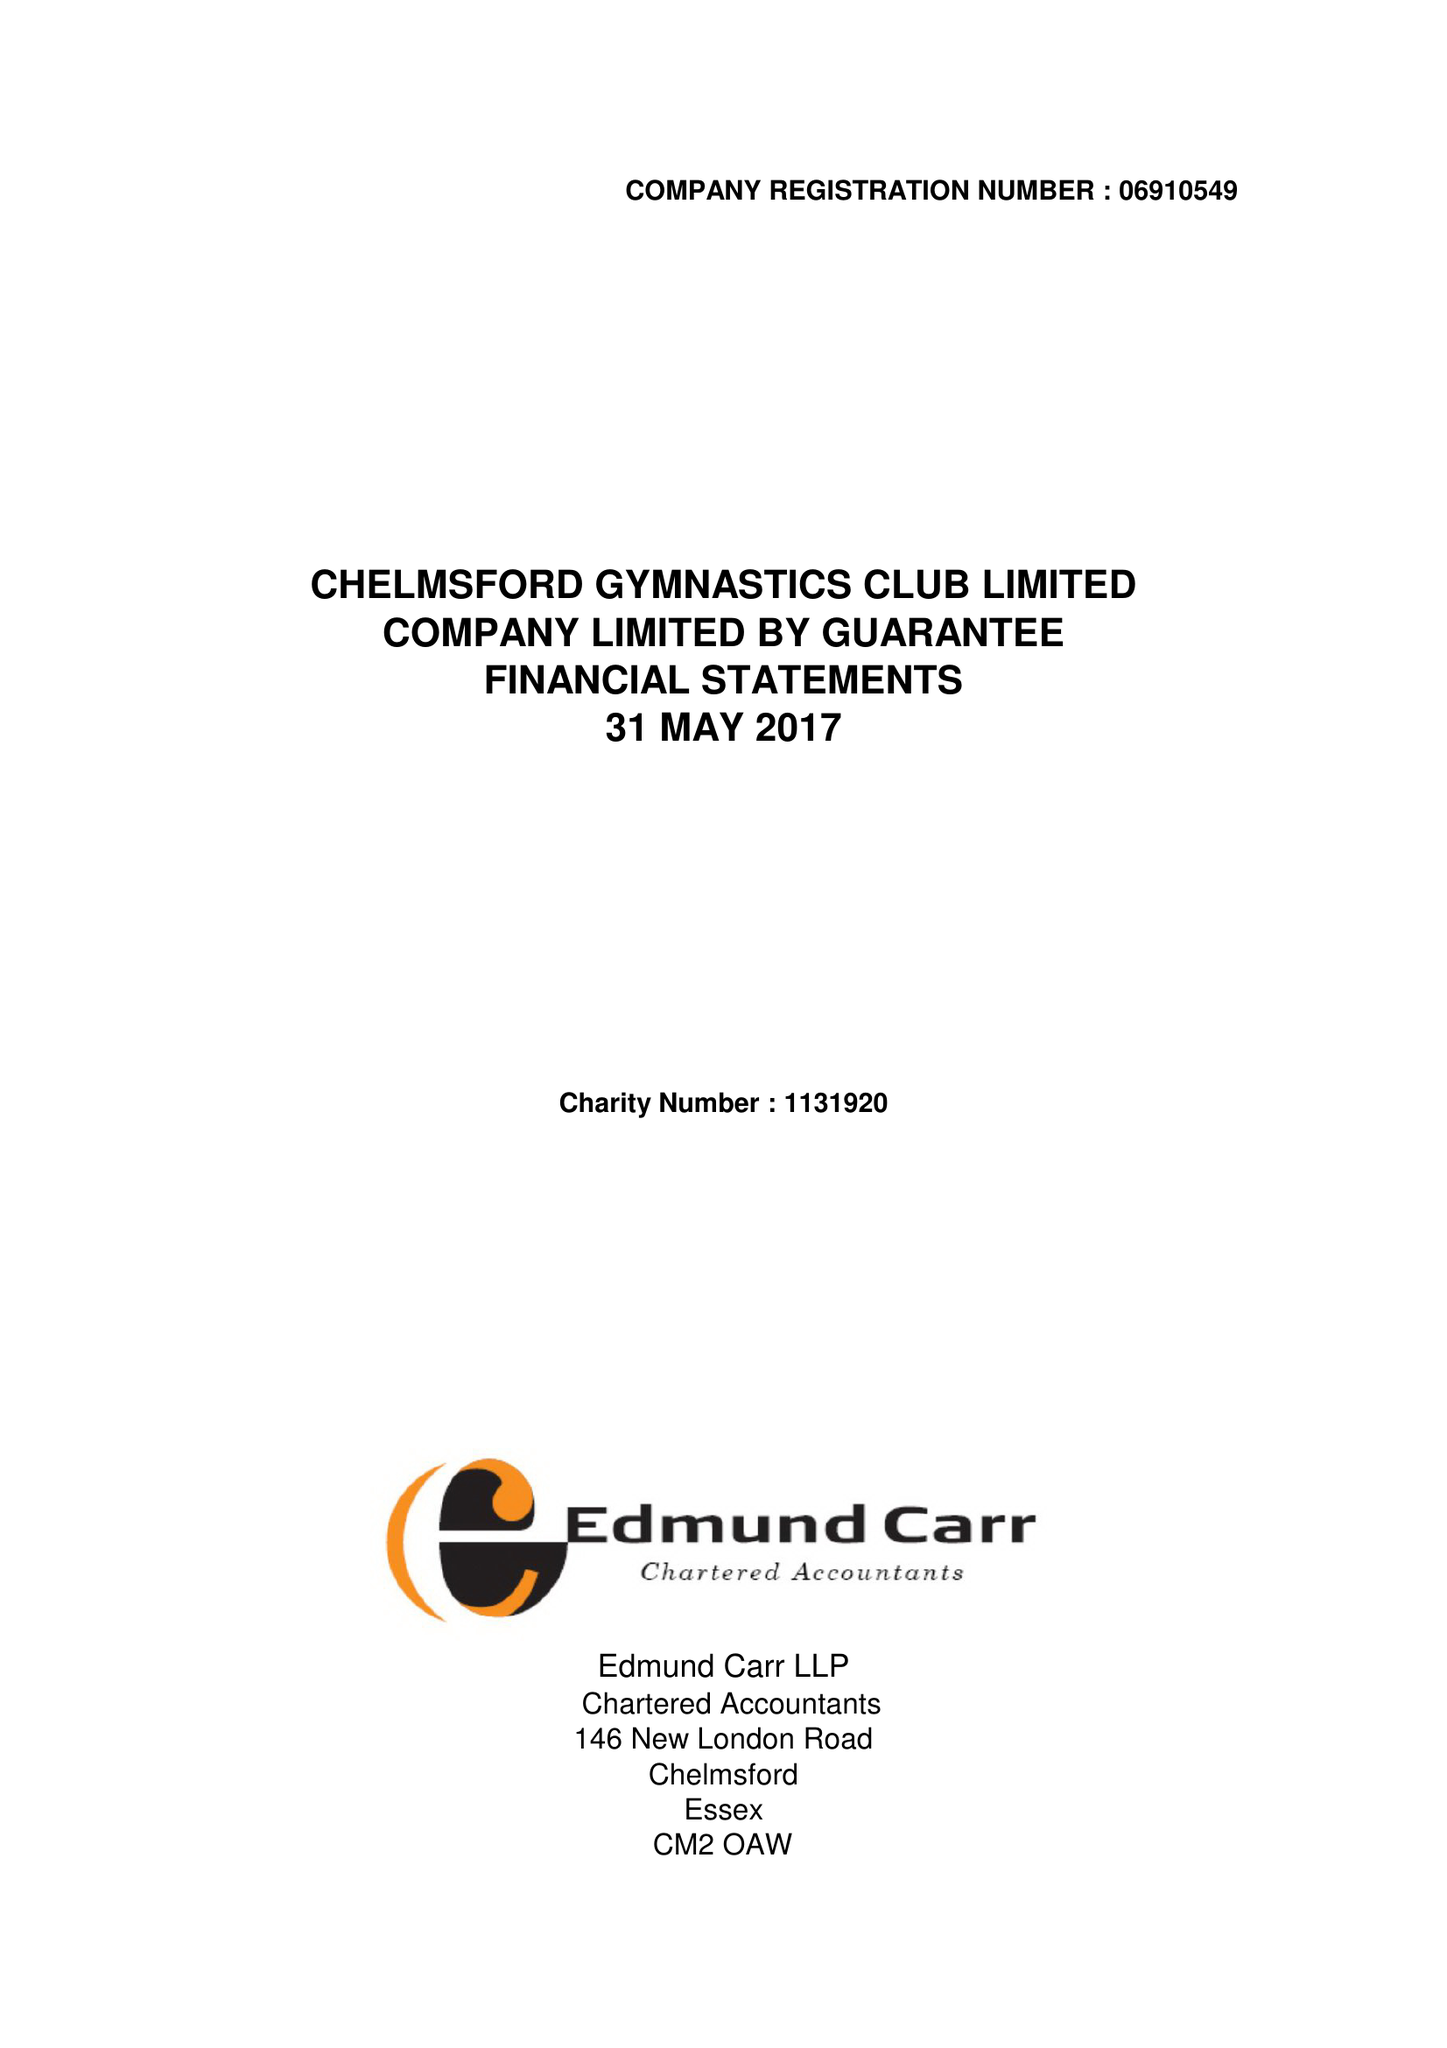What is the value for the income_annually_in_british_pounds?
Answer the question using a single word or phrase. 427861.00 